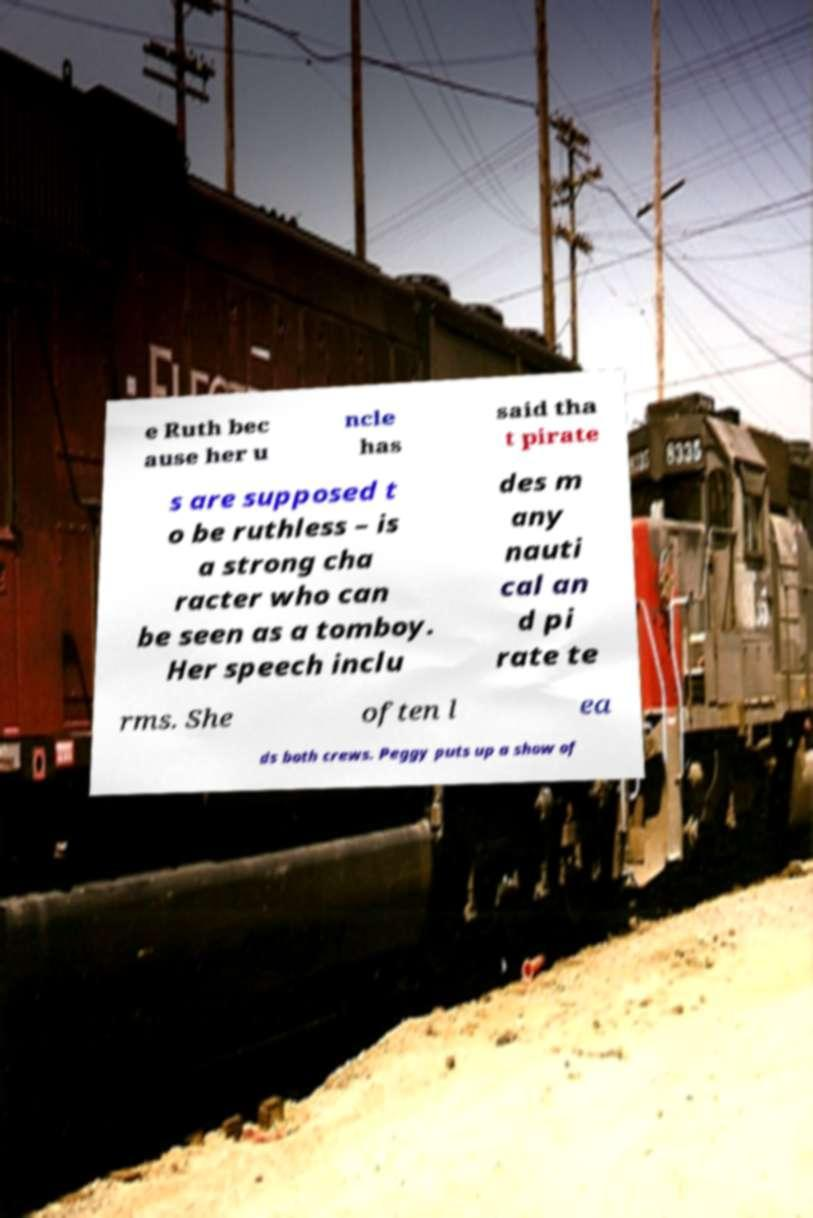There's text embedded in this image that I need extracted. Can you transcribe it verbatim? e Ruth bec ause her u ncle has said tha t pirate s are supposed t o be ruthless – is a strong cha racter who can be seen as a tomboy. Her speech inclu des m any nauti cal an d pi rate te rms. She often l ea ds both crews. Peggy puts up a show of 